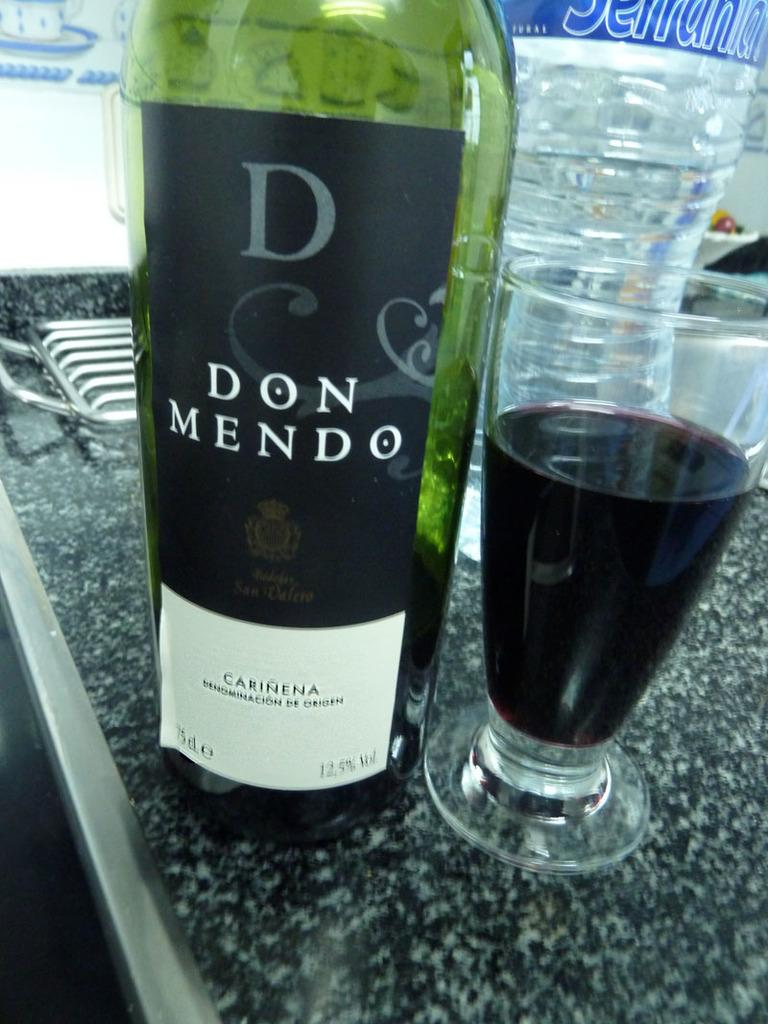<image>
Present a compact description of the photo's key features. the name Don is on the front of the green bottle 